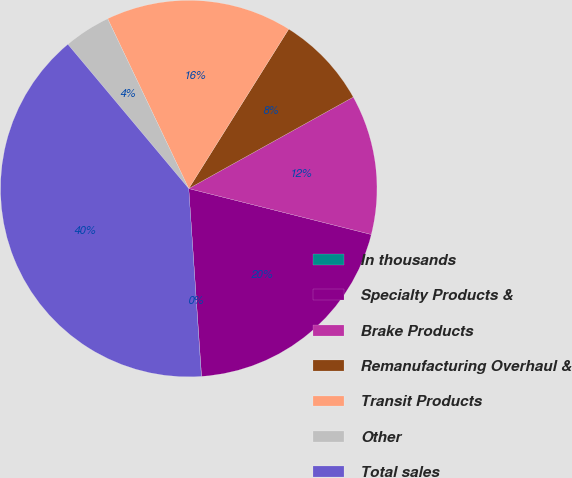Convert chart. <chart><loc_0><loc_0><loc_500><loc_500><pie_chart><fcel>In thousands<fcel>Specialty Products &<fcel>Brake Products<fcel>Remanufacturing Overhaul &<fcel>Transit Products<fcel>Other<fcel>Total sales<nl><fcel>0.02%<fcel>19.99%<fcel>12.0%<fcel>8.01%<fcel>16.0%<fcel>4.01%<fcel>39.97%<nl></chart> 